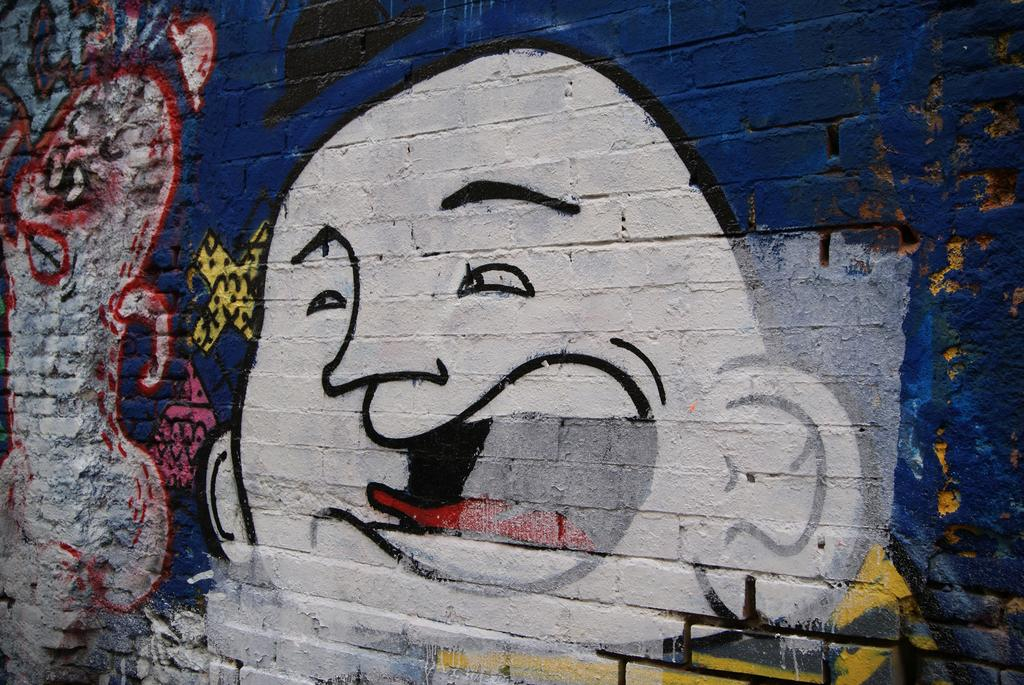What is present on the wall in the image? There is graffiti on a wall in the image. What type of hammer is being used to paint the graffiti in the image? There is no hammer present in the image, and graffiti is typically created using spray paint or markers rather than a hammer. 